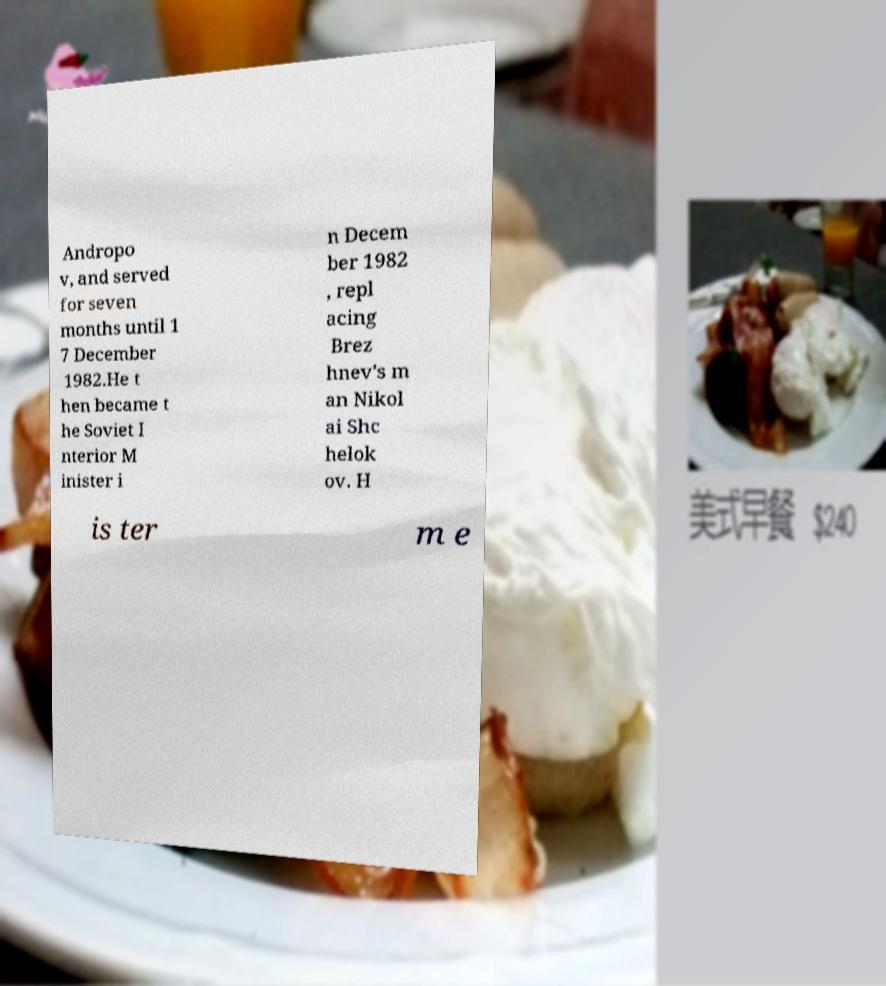Could you extract and type out the text from this image? Andropo v, and served for seven months until 1 7 December 1982.He t hen became t he Soviet I nterior M inister i n Decem ber 1982 , repl acing Brez hnev's m an Nikol ai Shc helok ov. H is ter m e 